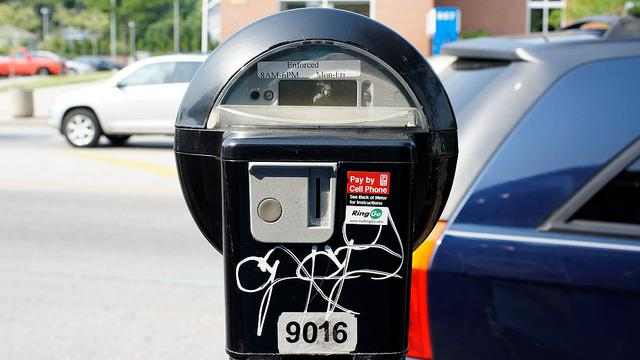What would someone need to do to use this device? Please explain your reasoning. park. A person would need to park. 